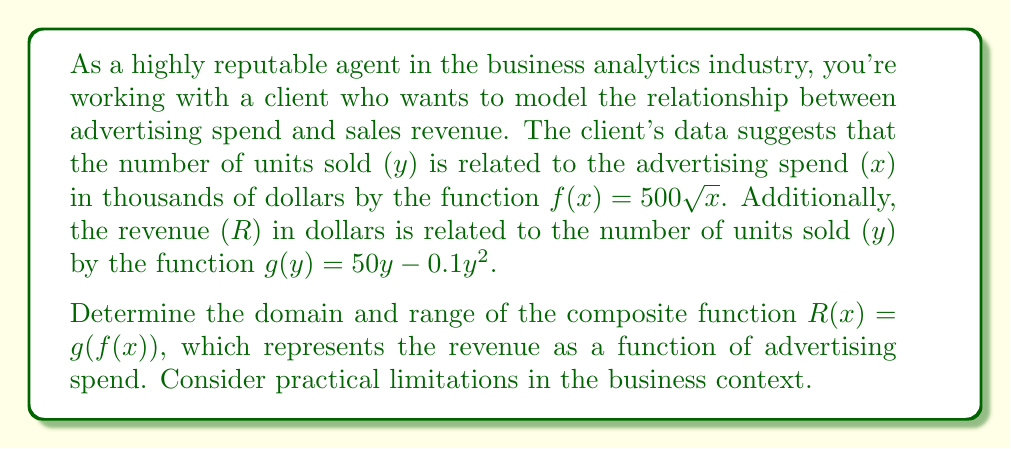Can you answer this question? To solve this problem, we'll follow these steps:

1. Identify the component functions:
   $f(x) = 500\sqrt{x}$
   $g(y) = 50y - 0.1y^2$

2. Form the composite function $R(x) = g(f(x))$:
   $R(x) = g(f(x)) = 50(500\sqrt{x}) - 0.1(500\sqrt{x})^2$
   $R(x) = 25000\sqrt{x} - 25000x$

3. Determine the domain:
   a) Mathematical domain:
      For $f(x)$, $x \geq 0$ (since we can't take the square root of a negative number)
      For $g(y)$, all real numbers are valid
   b) Practical domain:
      Advertising spend can't be negative, so $x \geq 0$
      There's likely an upper limit to advertising spend, let's say $x_{max}$

   Therefore, the domain is $[0, x_{max}]$

4. Determine the range:
   a) Find the maximum of $R(x)$:
      $R'(x) = \frac{12500}{\sqrt{x}} - 25000$
      Set $R'(x) = 0$ and solve:
      $\frac{12500}{\sqrt{x}} = 25000$
      $x = 0.25$

   b) Calculate $R(0.25)$:
      $R(0.25) = 25000\sqrt{0.25} - 25000(0.25) = 6250$

   c) Consider endpoints:
      $R(0) = 0$
      As $x$ approaches infinity, $R(x)$ approaches negative infinity

Therefore, the range is $[0, 6250]$
Answer: Domain: $[0, x_{max}]$, where $x_{max}$ is the practical upper limit of advertising spend.
Range: $[0, 6250]$ 